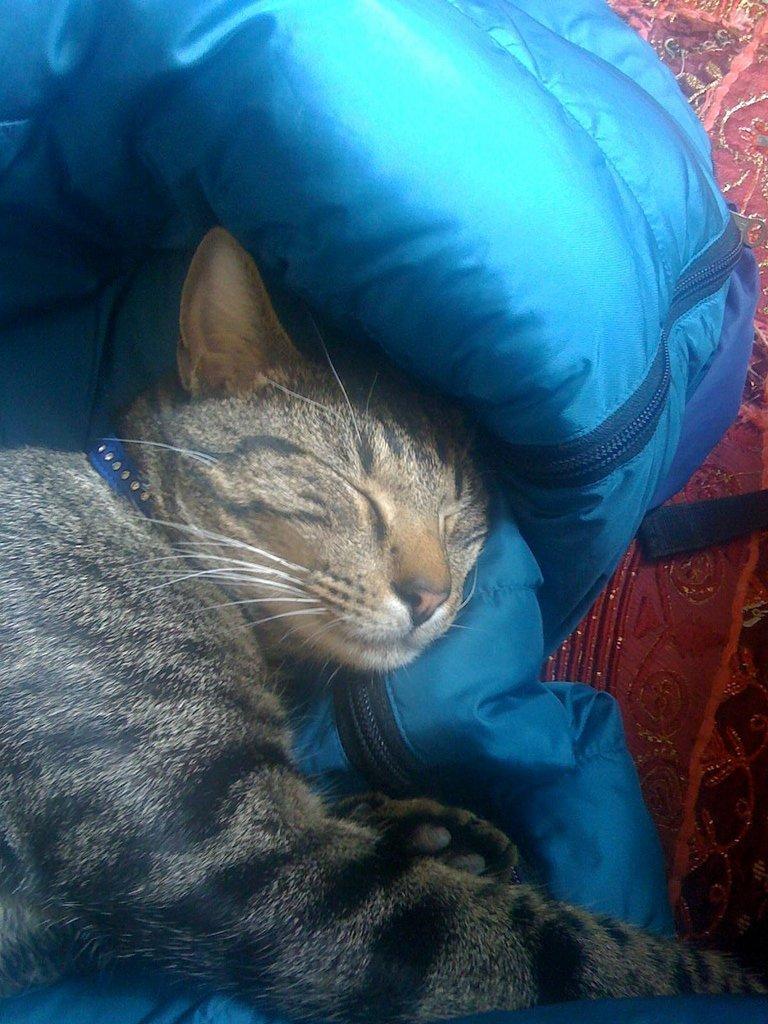Describe this image in one or two sentences. In this image, we can see a cat and a blue colored object. We can also see some cloth. 